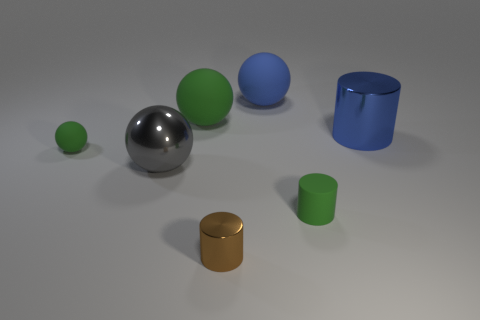Add 3 brown metallic cylinders. How many objects exist? 10 Subtract all red balls. Subtract all purple cubes. How many balls are left? 4 Subtract all cylinders. How many objects are left? 4 Add 2 large rubber things. How many large rubber things are left? 4 Add 6 small green things. How many small green things exist? 8 Subtract 0 red cylinders. How many objects are left? 7 Subtract all tiny purple shiny cubes. Subtract all green matte spheres. How many objects are left? 5 